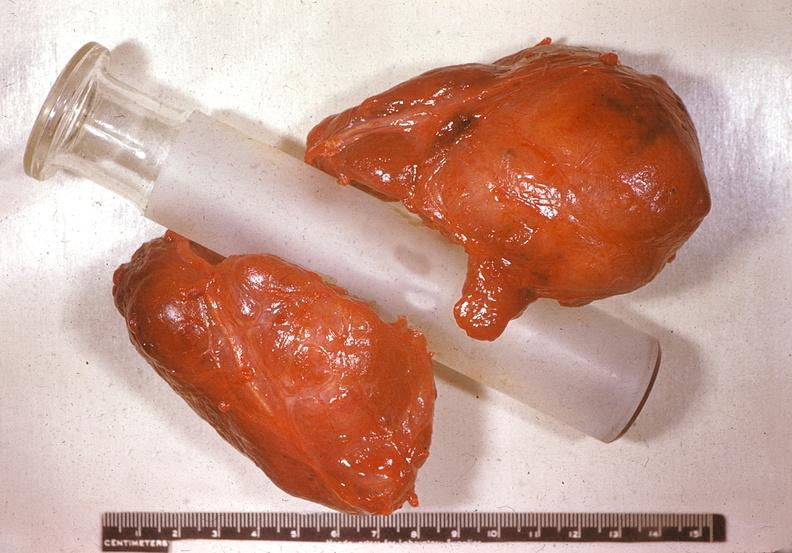what does this image show?
Answer the question using a single word or phrase. Thyroid 